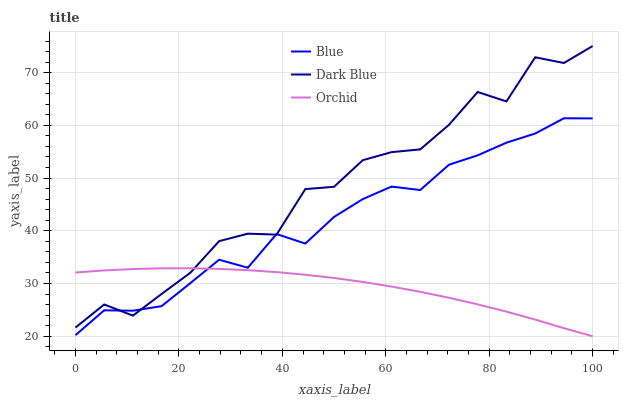Does Orchid have the minimum area under the curve?
Answer yes or no. Yes. Does Dark Blue have the maximum area under the curve?
Answer yes or no. Yes. Does Dark Blue have the minimum area under the curve?
Answer yes or no. No. Does Orchid have the maximum area under the curve?
Answer yes or no. No. Is Orchid the smoothest?
Answer yes or no. Yes. Is Dark Blue the roughest?
Answer yes or no. Yes. Is Dark Blue the smoothest?
Answer yes or no. No. Is Orchid the roughest?
Answer yes or no. No. Does Dark Blue have the lowest value?
Answer yes or no. No. Does Dark Blue have the highest value?
Answer yes or no. Yes. Does Orchid have the highest value?
Answer yes or no. No. Does Orchid intersect Dark Blue?
Answer yes or no. Yes. Is Orchid less than Dark Blue?
Answer yes or no. No. Is Orchid greater than Dark Blue?
Answer yes or no. No. 